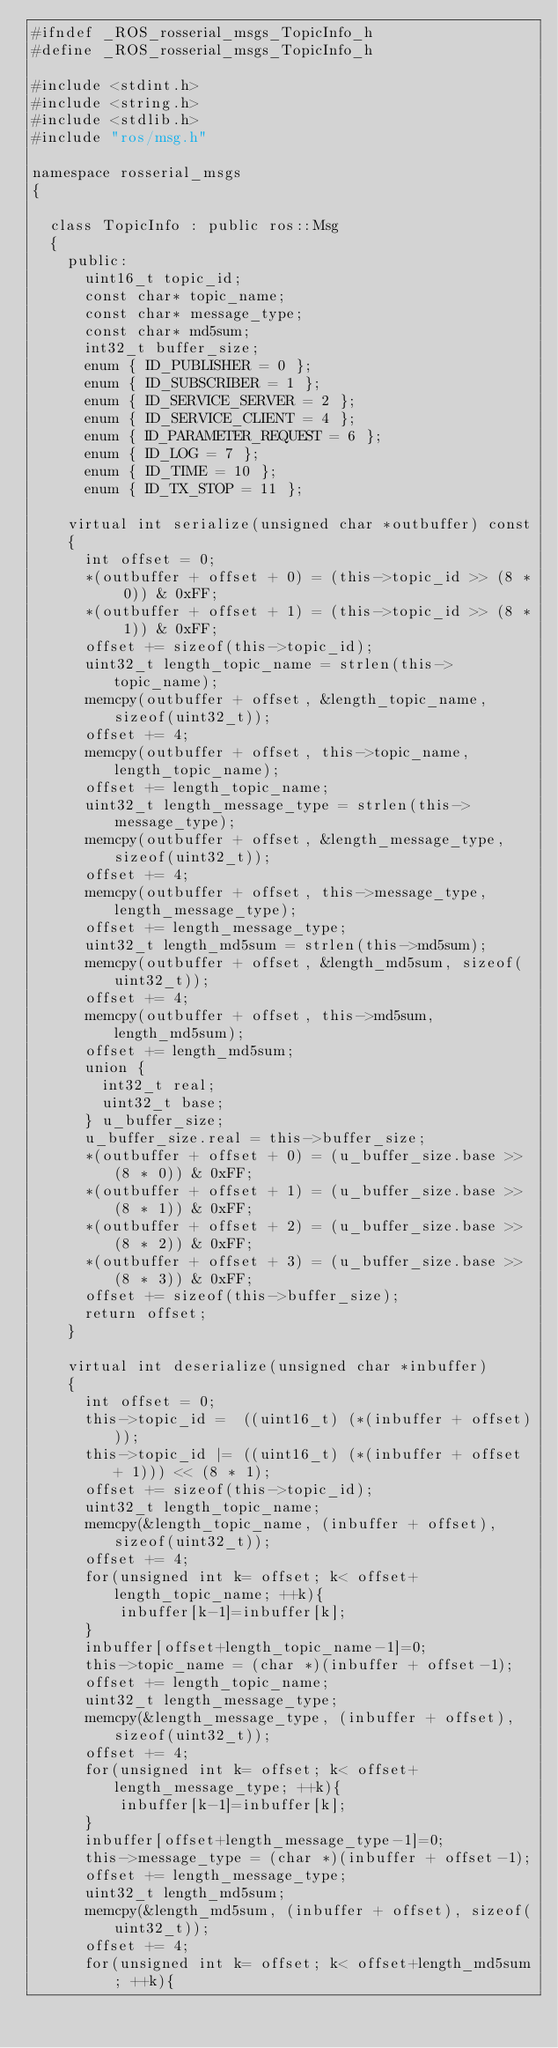<code> <loc_0><loc_0><loc_500><loc_500><_C_>#ifndef _ROS_rosserial_msgs_TopicInfo_h
#define _ROS_rosserial_msgs_TopicInfo_h

#include <stdint.h>
#include <string.h>
#include <stdlib.h>
#include "ros/msg.h"

namespace rosserial_msgs
{

  class TopicInfo : public ros::Msg
  {
    public:
      uint16_t topic_id;
      const char* topic_name;
      const char* message_type;
      const char* md5sum;
      int32_t buffer_size;
      enum { ID_PUBLISHER = 0 };
      enum { ID_SUBSCRIBER = 1 };
      enum { ID_SERVICE_SERVER = 2 };
      enum { ID_SERVICE_CLIENT = 4 };
      enum { ID_PARAMETER_REQUEST = 6 };
      enum { ID_LOG = 7 };
      enum { ID_TIME = 10 };
      enum { ID_TX_STOP = 11 };

    virtual int serialize(unsigned char *outbuffer) const
    {
      int offset = 0;
      *(outbuffer + offset + 0) = (this->topic_id >> (8 * 0)) & 0xFF;
      *(outbuffer + offset + 1) = (this->topic_id >> (8 * 1)) & 0xFF;
      offset += sizeof(this->topic_id);
      uint32_t length_topic_name = strlen(this->topic_name);
      memcpy(outbuffer + offset, &length_topic_name, sizeof(uint32_t));
      offset += 4;
      memcpy(outbuffer + offset, this->topic_name, length_topic_name);
      offset += length_topic_name;
      uint32_t length_message_type = strlen(this->message_type);
      memcpy(outbuffer + offset, &length_message_type, sizeof(uint32_t));
      offset += 4;
      memcpy(outbuffer + offset, this->message_type, length_message_type);
      offset += length_message_type;
      uint32_t length_md5sum = strlen(this->md5sum);
      memcpy(outbuffer + offset, &length_md5sum, sizeof(uint32_t));
      offset += 4;
      memcpy(outbuffer + offset, this->md5sum, length_md5sum);
      offset += length_md5sum;
      union {
        int32_t real;
        uint32_t base;
      } u_buffer_size;
      u_buffer_size.real = this->buffer_size;
      *(outbuffer + offset + 0) = (u_buffer_size.base >> (8 * 0)) & 0xFF;
      *(outbuffer + offset + 1) = (u_buffer_size.base >> (8 * 1)) & 0xFF;
      *(outbuffer + offset + 2) = (u_buffer_size.base >> (8 * 2)) & 0xFF;
      *(outbuffer + offset + 3) = (u_buffer_size.base >> (8 * 3)) & 0xFF;
      offset += sizeof(this->buffer_size);
      return offset;
    }

    virtual int deserialize(unsigned char *inbuffer)
    {
      int offset = 0;
      this->topic_id =  ((uint16_t) (*(inbuffer + offset)));
      this->topic_id |= ((uint16_t) (*(inbuffer + offset + 1))) << (8 * 1);
      offset += sizeof(this->topic_id);
      uint32_t length_topic_name;
      memcpy(&length_topic_name, (inbuffer + offset), sizeof(uint32_t));
      offset += 4;
      for(unsigned int k= offset; k< offset+length_topic_name; ++k){
          inbuffer[k-1]=inbuffer[k];
      }
      inbuffer[offset+length_topic_name-1]=0;
      this->topic_name = (char *)(inbuffer + offset-1);
      offset += length_topic_name;
      uint32_t length_message_type;
      memcpy(&length_message_type, (inbuffer + offset), sizeof(uint32_t));
      offset += 4;
      for(unsigned int k= offset; k< offset+length_message_type; ++k){
          inbuffer[k-1]=inbuffer[k];
      }
      inbuffer[offset+length_message_type-1]=0;
      this->message_type = (char *)(inbuffer + offset-1);
      offset += length_message_type;
      uint32_t length_md5sum;
      memcpy(&length_md5sum, (inbuffer + offset), sizeof(uint32_t));
      offset += 4;
      for(unsigned int k= offset; k< offset+length_md5sum; ++k){</code> 